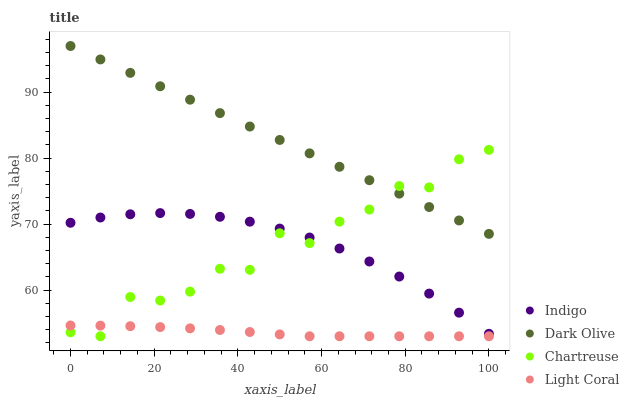Does Light Coral have the minimum area under the curve?
Answer yes or no. Yes. Does Dark Olive have the maximum area under the curve?
Answer yes or no. Yes. Does Chartreuse have the minimum area under the curve?
Answer yes or no. No. Does Chartreuse have the maximum area under the curve?
Answer yes or no. No. Is Dark Olive the smoothest?
Answer yes or no. Yes. Is Chartreuse the roughest?
Answer yes or no. Yes. Is Chartreuse the smoothest?
Answer yes or no. No. Is Dark Olive the roughest?
Answer yes or no. No. Does Light Coral have the lowest value?
Answer yes or no. Yes. Does Dark Olive have the lowest value?
Answer yes or no. No. Does Dark Olive have the highest value?
Answer yes or no. Yes. Does Chartreuse have the highest value?
Answer yes or no. No. Is Indigo less than Dark Olive?
Answer yes or no. Yes. Is Dark Olive greater than Light Coral?
Answer yes or no. Yes. Does Chartreuse intersect Light Coral?
Answer yes or no. Yes. Is Chartreuse less than Light Coral?
Answer yes or no. No. Is Chartreuse greater than Light Coral?
Answer yes or no. No. Does Indigo intersect Dark Olive?
Answer yes or no. No. 